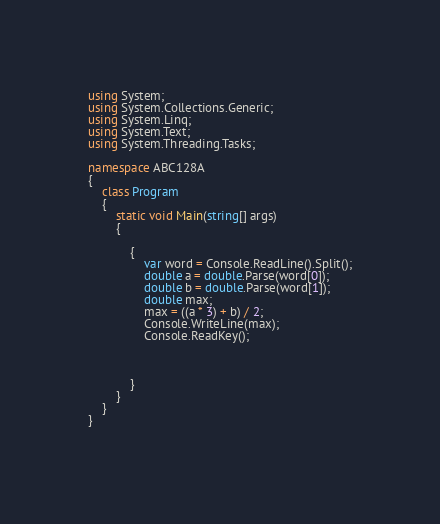Convert code to text. <code><loc_0><loc_0><loc_500><loc_500><_C#_>using System;
using System.Collections.Generic;
using System.Linq;
using System.Text;
using System.Threading.Tasks;

namespace ABC128A
{
    class Program
    {
        static void Main(string[] args)
        {
          
            {
                var word = Console.ReadLine().Split();
                double a = double.Parse(word[0]);
                double b = double.Parse(word[1]);
                double max;
                max = ((a * 3) + b) / 2;
                Console.WriteLine(max);
                Console.ReadKey();



            }
        }
    }
}
    
</code> 